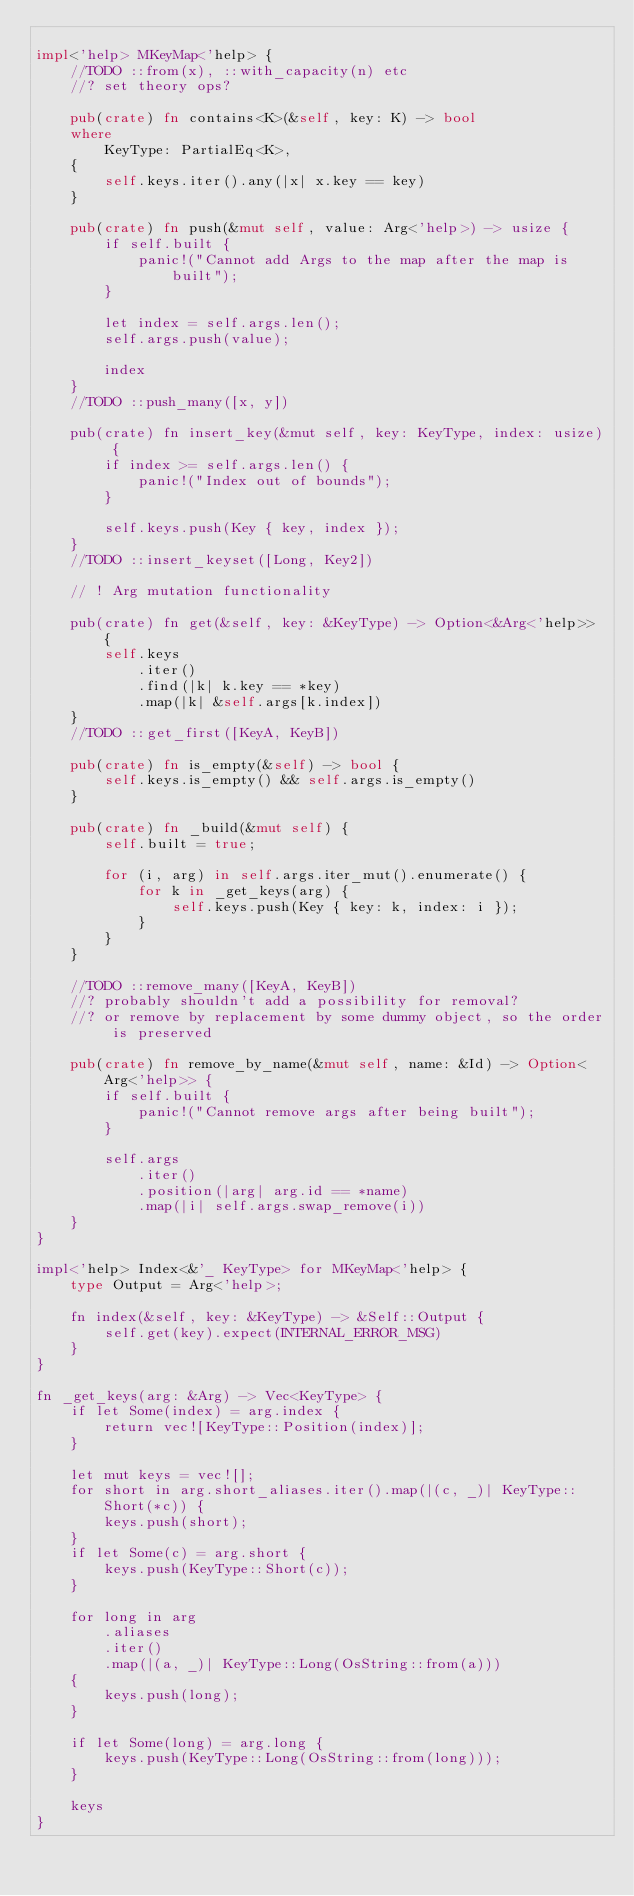Convert code to text. <code><loc_0><loc_0><loc_500><loc_500><_Rust_>
impl<'help> MKeyMap<'help> {
    //TODO ::from(x), ::with_capacity(n) etc
    //? set theory ops?

    pub(crate) fn contains<K>(&self, key: K) -> bool
    where
        KeyType: PartialEq<K>,
    {
        self.keys.iter().any(|x| x.key == key)
    }

    pub(crate) fn push(&mut self, value: Arg<'help>) -> usize {
        if self.built {
            panic!("Cannot add Args to the map after the map is built");
        }

        let index = self.args.len();
        self.args.push(value);

        index
    }
    //TODO ::push_many([x, y])

    pub(crate) fn insert_key(&mut self, key: KeyType, index: usize) {
        if index >= self.args.len() {
            panic!("Index out of bounds");
        }

        self.keys.push(Key { key, index });
    }
    //TODO ::insert_keyset([Long, Key2])

    // ! Arg mutation functionality

    pub(crate) fn get(&self, key: &KeyType) -> Option<&Arg<'help>> {
        self.keys
            .iter()
            .find(|k| k.key == *key)
            .map(|k| &self.args[k.index])
    }
    //TODO ::get_first([KeyA, KeyB])

    pub(crate) fn is_empty(&self) -> bool {
        self.keys.is_empty() && self.args.is_empty()
    }

    pub(crate) fn _build(&mut self) {
        self.built = true;

        for (i, arg) in self.args.iter_mut().enumerate() {
            for k in _get_keys(arg) {
                self.keys.push(Key { key: k, index: i });
            }
        }
    }

    //TODO ::remove_many([KeyA, KeyB])
    //? probably shouldn't add a possibility for removal?
    //? or remove by replacement by some dummy object, so the order is preserved

    pub(crate) fn remove_by_name(&mut self, name: &Id) -> Option<Arg<'help>> {
        if self.built {
            panic!("Cannot remove args after being built");
        }

        self.args
            .iter()
            .position(|arg| arg.id == *name)
            .map(|i| self.args.swap_remove(i))
    }
}

impl<'help> Index<&'_ KeyType> for MKeyMap<'help> {
    type Output = Arg<'help>;

    fn index(&self, key: &KeyType) -> &Self::Output {
        self.get(key).expect(INTERNAL_ERROR_MSG)
    }
}

fn _get_keys(arg: &Arg) -> Vec<KeyType> {
    if let Some(index) = arg.index {
        return vec![KeyType::Position(index)];
    }

    let mut keys = vec![];
    for short in arg.short_aliases.iter().map(|(c, _)| KeyType::Short(*c)) {
        keys.push(short);
    }
    if let Some(c) = arg.short {
        keys.push(KeyType::Short(c));
    }

    for long in arg
        .aliases
        .iter()
        .map(|(a, _)| KeyType::Long(OsString::from(a)))
    {
        keys.push(long);
    }

    if let Some(long) = arg.long {
        keys.push(KeyType::Long(OsString::from(long)));
    }

    keys
}
</code> 